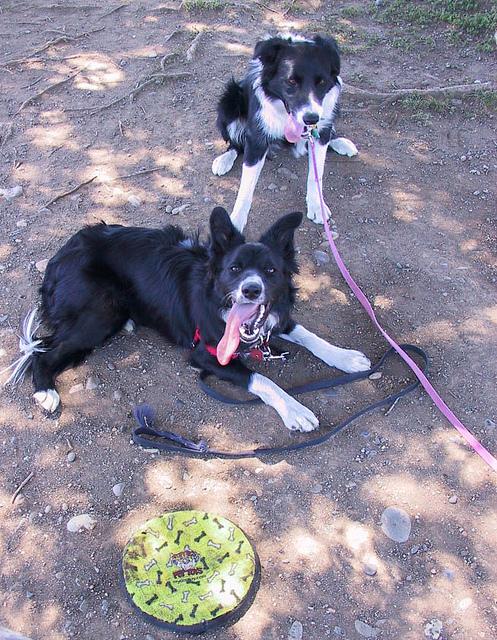What color are the dogs teeth?
Answer briefly. White. Which side of the face is the dogs tail wagging?
Quick response, please. Right. Are the dogs thirsty?
Quick response, please. Yes. 